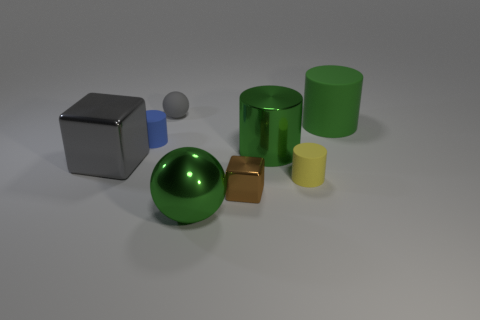What shape is the large metal thing that is the same color as the big metallic ball?
Offer a very short reply. Cylinder. There is a rubber cylinder that is the same color as the big metallic cylinder; what size is it?
Provide a short and direct response. Large. There is a block that is in front of the rubber object that is in front of the large green cylinder that is to the left of the green matte cylinder; what is its size?
Ensure brevity in your answer.  Small. How many large green objects are made of the same material as the small sphere?
Offer a terse response. 1. There is a tiny cylinder behind the big metal cylinder that is to the right of the brown metal thing; what is its color?
Ensure brevity in your answer.  Blue. How many objects are tiny brown matte spheres or big green objects that are in front of the large shiny cylinder?
Your response must be concise. 1. Are there any matte balls of the same color as the shiny sphere?
Provide a short and direct response. No. How many blue objects are blocks or big rubber things?
Give a very brief answer. 0. What number of other objects are the same size as the blue cylinder?
Your answer should be compact. 3. How many tiny objects are gray rubber things or gray things?
Offer a very short reply. 1. 